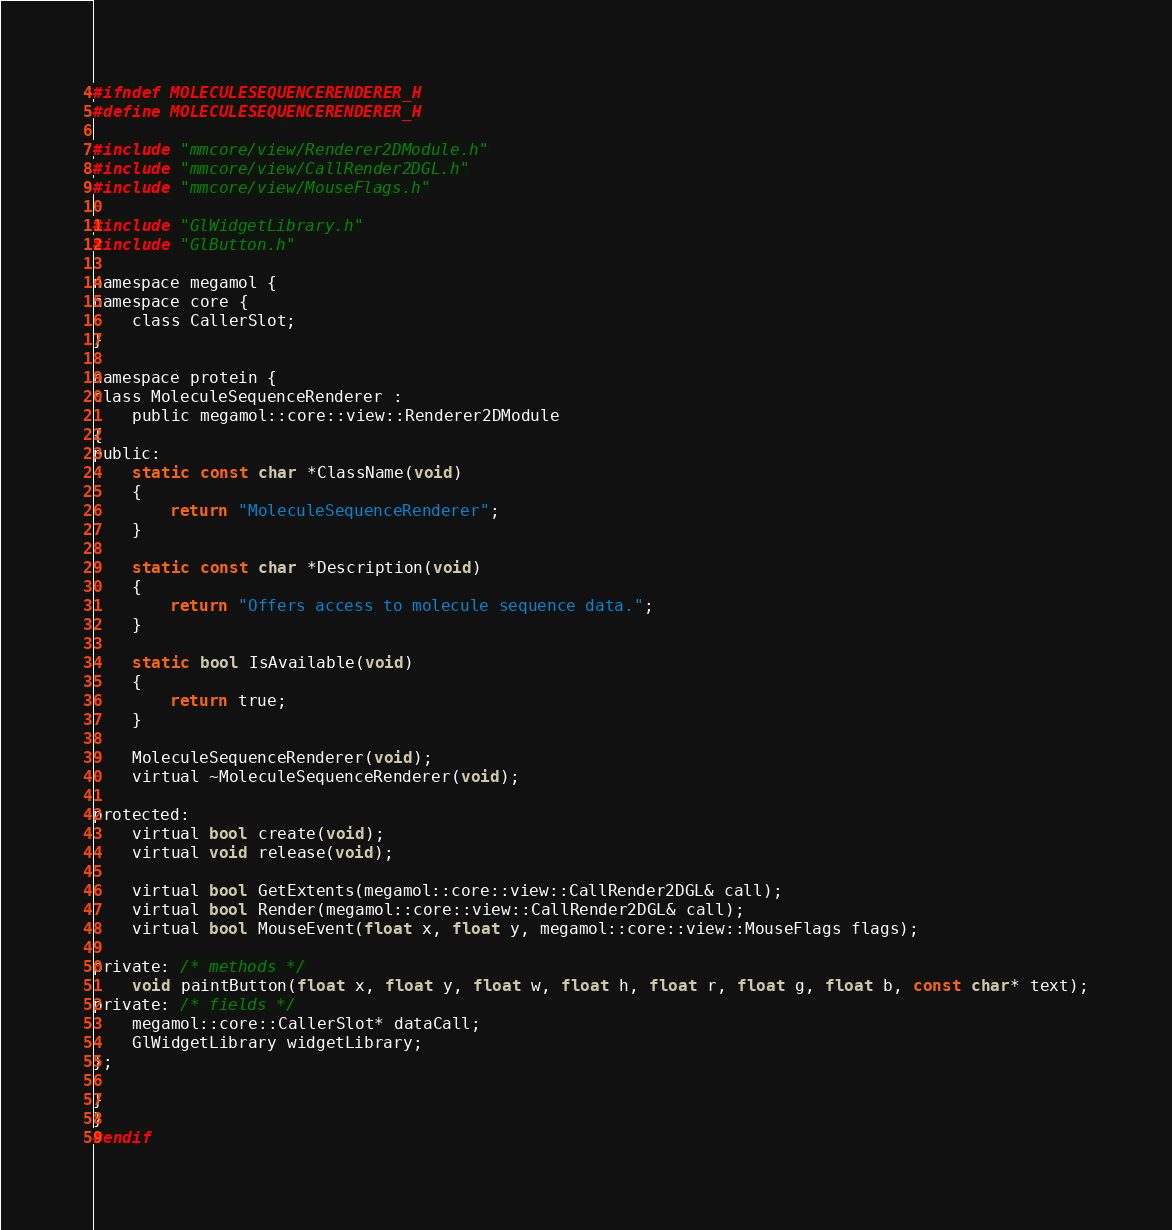Convert code to text. <code><loc_0><loc_0><loc_500><loc_500><_C_>#ifndef MOLECULESEQUENCERENDERER_H
#define MOLECULESEQUENCERENDERER_H

#include "mmcore/view/Renderer2DModule.h"
#include "mmcore/view/CallRender2DGL.h"
#include "mmcore/view/MouseFlags.h"

#include "GlWidgetLibrary.h"
#include "GlButton.h"

namespace megamol {
namespace core {
	class CallerSlot;
}

namespace protein {
class MoleculeSequenceRenderer :
	public megamol::core::view::Renderer2DModule
{
public:
    static const char *ClassName(void)
    {
        return "MoleculeSequenceRenderer";
    }

    static const char *Description(void)
    {
        return "Offers access to molecule sequence data.";
    }

    static bool IsAvailable(void) 
    {
        return true;
    }

	MoleculeSequenceRenderer(void);
	virtual ~MoleculeSequenceRenderer(void);

protected:
    virtual bool create(void);
    virtual void release(void);

    virtual bool GetExtents(megamol::core::view::CallRender2DGL& call);
	virtual bool Render(megamol::core::view::CallRender2DGL& call);
    virtual bool MouseEvent(float x, float y, megamol::core::view::MouseFlags flags);
	
private: /* methods */
	void paintButton(float x, float y, float w, float h, float r, float g, float b, const char* text);
private: /* fields */
	megamol::core::CallerSlot* dataCall;
	GlWidgetLibrary widgetLibrary;
};

}
}
#endif
</code> 